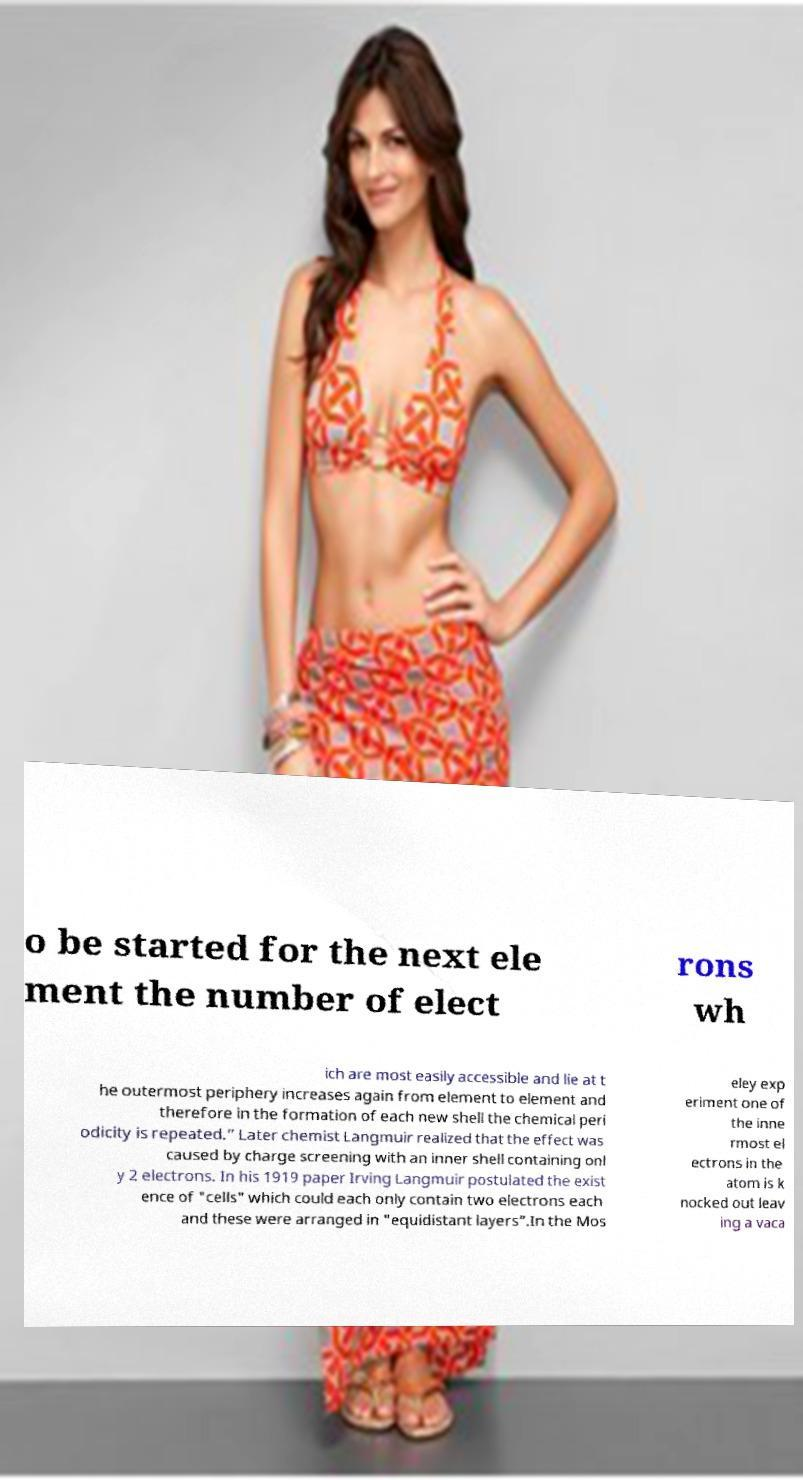Please identify and transcribe the text found in this image. o be started for the next ele ment the number of elect rons wh ich are most easily accessible and lie at t he outermost periphery increases again from element to element and therefore in the formation of each new shell the chemical peri odicity is repeated.” Later chemist Langmuir realized that the effect was caused by charge screening with an inner shell containing onl y 2 electrons. In his 1919 paper Irving Langmuir postulated the exist ence of "cells" which could each only contain two electrons each and these were arranged in "equidistant layers”.In the Mos eley exp eriment one of the inne rmost el ectrons in the atom is k nocked out leav ing a vaca 